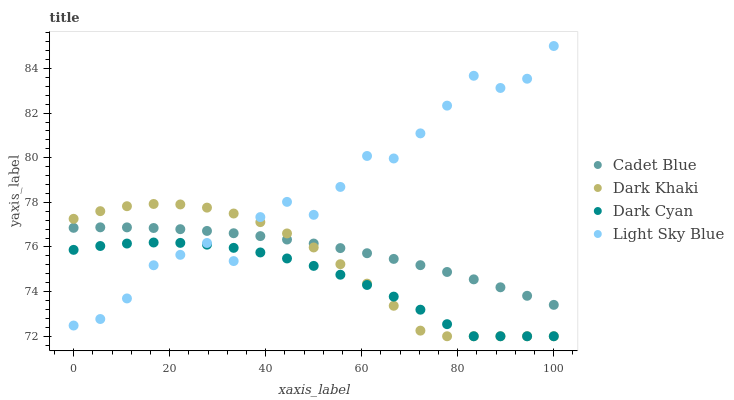Does Dark Cyan have the minimum area under the curve?
Answer yes or no. Yes. Does Light Sky Blue have the maximum area under the curve?
Answer yes or no. Yes. Does Cadet Blue have the minimum area under the curve?
Answer yes or no. No. Does Cadet Blue have the maximum area under the curve?
Answer yes or no. No. Is Cadet Blue the smoothest?
Answer yes or no. Yes. Is Light Sky Blue the roughest?
Answer yes or no. Yes. Is Dark Cyan the smoothest?
Answer yes or no. No. Is Dark Cyan the roughest?
Answer yes or no. No. Does Dark Khaki have the lowest value?
Answer yes or no. Yes. Does Cadet Blue have the lowest value?
Answer yes or no. No. Does Light Sky Blue have the highest value?
Answer yes or no. Yes. Does Cadet Blue have the highest value?
Answer yes or no. No. Is Dark Cyan less than Cadet Blue?
Answer yes or no. Yes. Is Cadet Blue greater than Dark Cyan?
Answer yes or no. Yes. Does Cadet Blue intersect Dark Khaki?
Answer yes or no. Yes. Is Cadet Blue less than Dark Khaki?
Answer yes or no. No. Is Cadet Blue greater than Dark Khaki?
Answer yes or no. No. Does Dark Cyan intersect Cadet Blue?
Answer yes or no. No. 